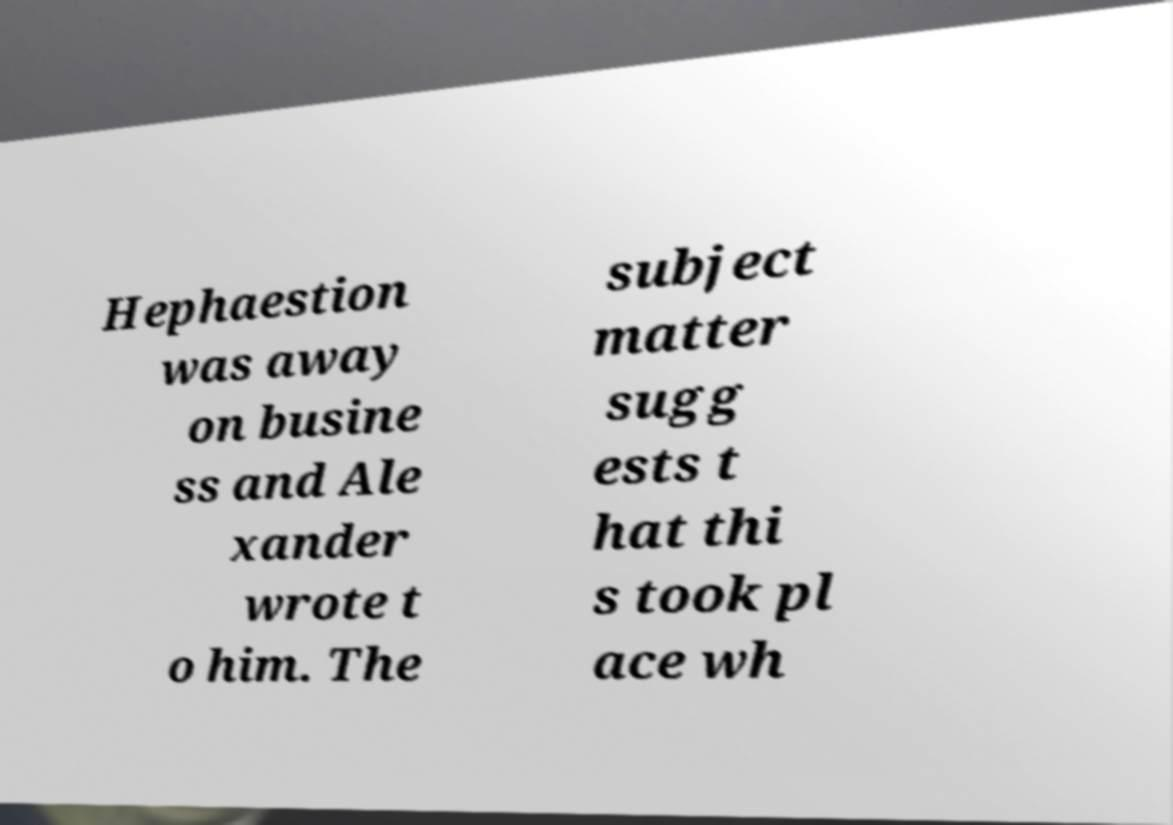Can you read and provide the text displayed in the image?This photo seems to have some interesting text. Can you extract and type it out for me? Hephaestion was away on busine ss and Ale xander wrote t o him. The subject matter sugg ests t hat thi s took pl ace wh 